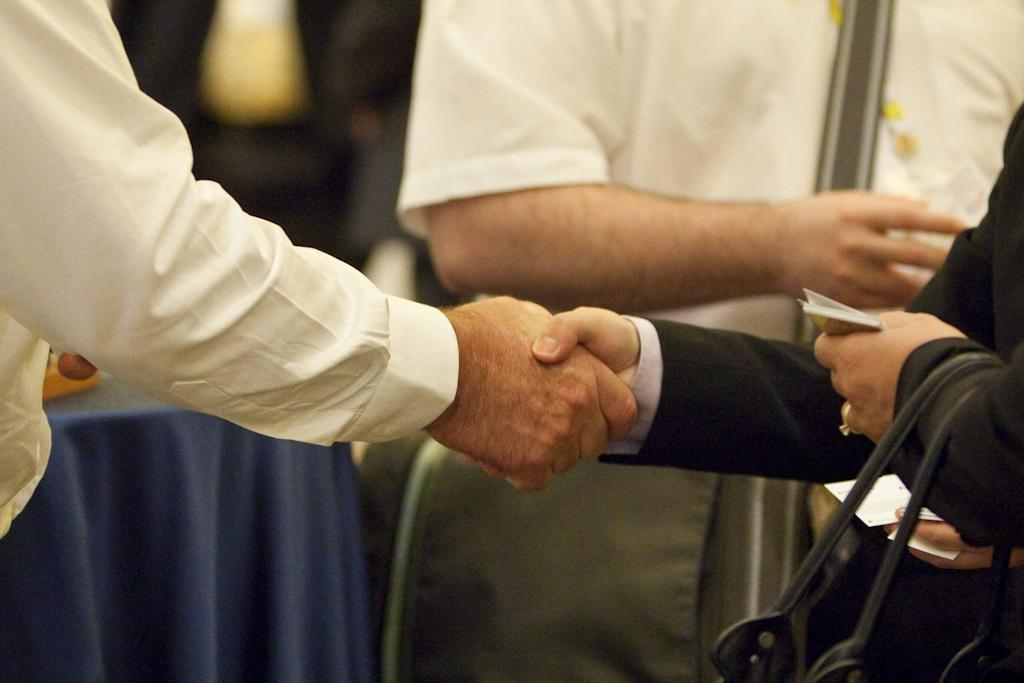What are the two people in the foreground of the image doing? The two people in the foreground of the image are shaking hands. Can you describe the people in the background of the image? There are other people in the background of the image, but their specific actions or appearances cannot be determined from the provided facts. What type of oatmeal is being served at the event in the image? There is no mention of oatmeal or any event in the image, so it cannot be determined if oatmeal is being served or if there is an event taking place. 